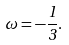Convert formula to latex. <formula><loc_0><loc_0><loc_500><loc_500>\omega = - \frac { 1 } { 3 } .</formula> 